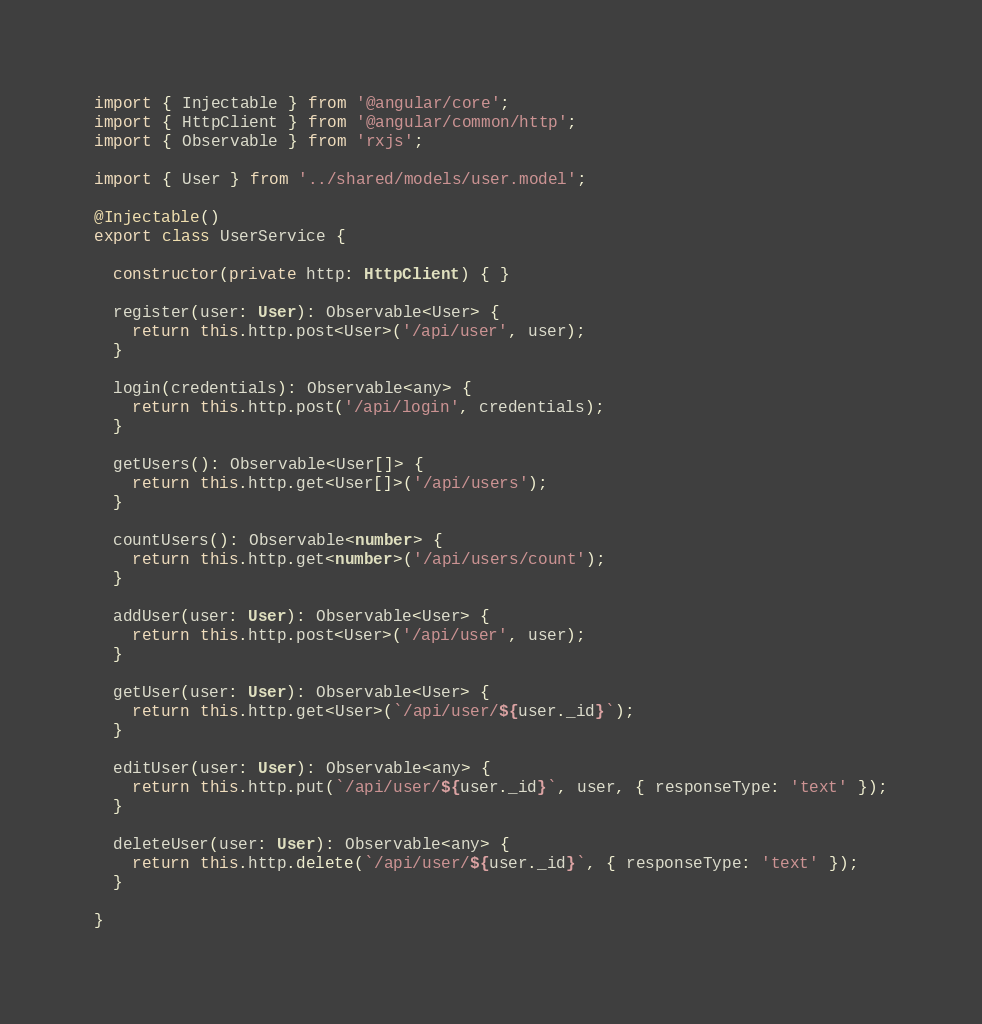Convert code to text. <code><loc_0><loc_0><loc_500><loc_500><_TypeScript_>import { Injectable } from '@angular/core';
import { HttpClient } from '@angular/common/http';
import { Observable } from 'rxjs';

import { User } from '../shared/models/user.model';

@Injectable()
export class UserService {

  constructor(private http: HttpClient) { }

  register(user: User): Observable<User> {
    return this.http.post<User>('/api/user', user);
  }

  login(credentials): Observable<any> {
    return this.http.post('/api/login', credentials);
  }

  getUsers(): Observable<User[]> {
    return this.http.get<User[]>('/api/users');
  }

  countUsers(): Observable<number> {
    return this.http.get<number>('/api/users/count');
  }

  addUser(user: User): Observable<User> {
    return this.http.post<User>('/api/user', user);
  }

  getUser(user: User): Observable<User> {
    return this.http.get<User>(`/api/user/${user._id}`);
  }

  editUser(user: User): Observable<any> {
    return this.http.put(`/api/user/${user._id}`, user, { responseType: 'text' });
  }

  deleteUser(user: User): Observable<any> {
    return this.http.delete(`/api/user/${user._id}`, { responseType: 'text' });
  }

}
</code> 